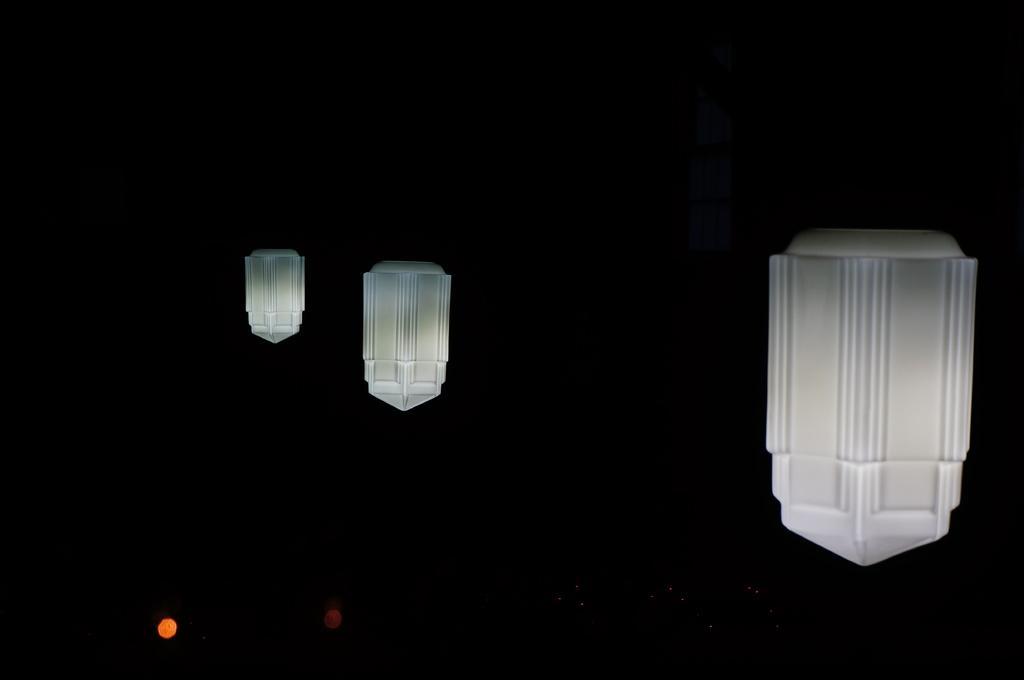Describe this image in one or two sentences. On the left side, there are two yellow and white color lights arranged. On the right side, there is a white color light arranged. And the background is dark in color. 